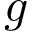<formula> <loc_0><loc_0><loc_500><loc_500>g</formula> 